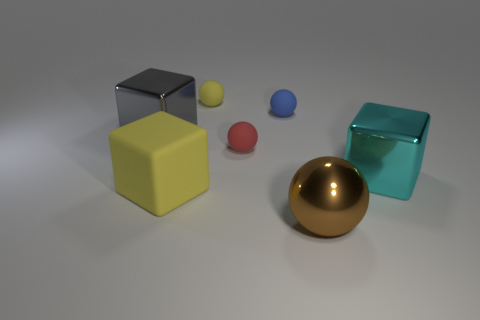Subtract all big shiny cubes. How many cubes are left? 1 Subtract all yellow balls. How many balls are left? 3 Subtract 2 cubes. How many cubes are left? 1 Subtract all blocks. How many objects are left? 4 Subtract all yellow spheres. How many cyan cubes are left? 1 Add 6 big gray metallic blocks. How many big gray metallic blocks are left? 7 Add 4 large matte objects. How many large matte objects exist? 5 Add 2 yellow things. How many objects exist? 9 Subtract 1 cyan blocks. How many objects are left? 6 Subtract all blue blocks. Subtract all gray spheres. How many blocks are left? 3 